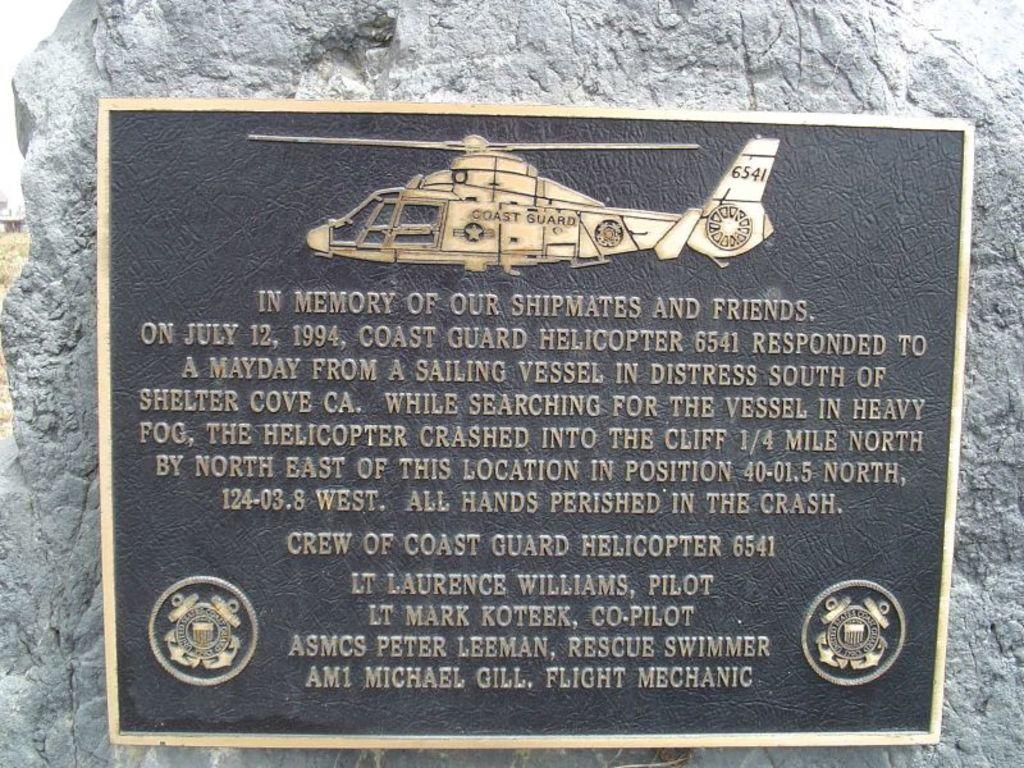What is the main object in the image? There is a blackboard in the image. What is written or drawn on the blackboard? Text is written on the blackboard. Can you describe anything in the background of the image? There is a stone visible in the background of the image. Can you tell me how many cattle are grazing near the stream in the image? There is no stream or cattle present in the image; it features a blackboard with text and a stone in the background. 